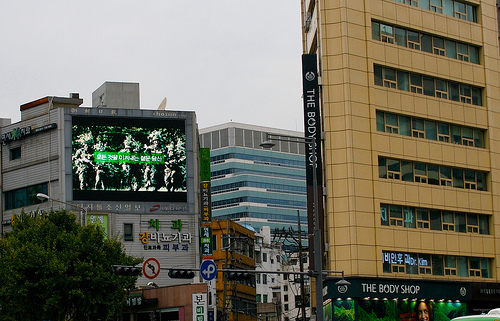<image>
Is there a movie screen above the entrance? Yes. The movie screen is positioned above the entrance in the vertical space, higher up in the scene. 